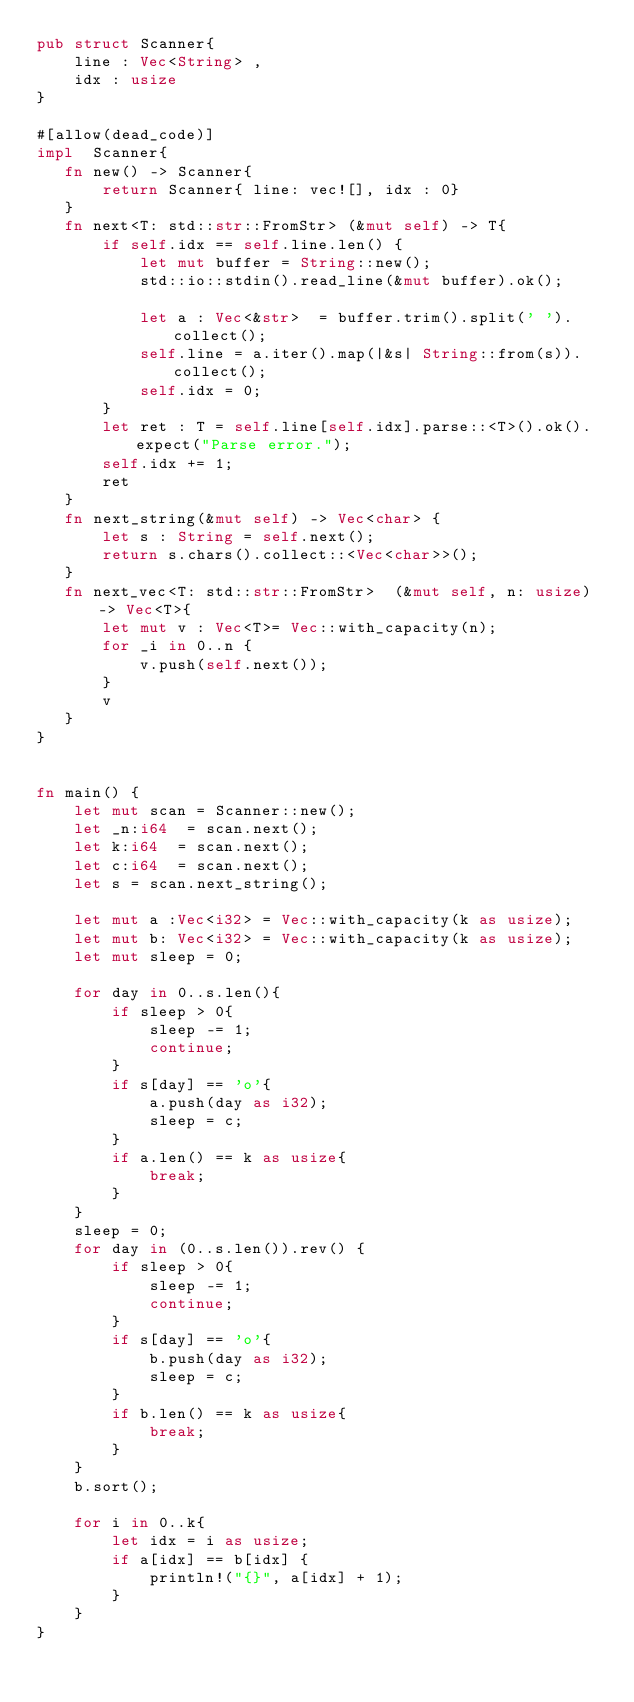Convert code to text. <code><loc_0><loc_0><loc_500><loc_500><_Rust_>pub struct Scanner{
    line : Vec<String> ,
    idx : usize
}

#[allow(dead_code)]
impl  Scanner{
   fn new() -> Scanner{
       return Scanner{ line: vec![], idx : 0}
   }
   fn next<T: std::str::FromStr> (&mut self) -> T{
       if self.idx == self.line.len() {
           let mut buffer = String::new();
           std::io::stdin().read_line(&mut buffer).ok();

           let a : Vec<&str>  = buffer.trim().split(' ').collect();
           self.line = a.iter().map(|&s| String::from(s)).collect();
           self.idx = 0;
       }
       let ret : T = self.line[self.idx].parse::<T>().ok().expect("Parse error.");
       self.idx += 1;
       ret
   }
   fn next_string(&mut self) -> Vec<char> {
       let s : String = self.next();
       return s.chars().collect::<Vec<char>>();
   }
   fn next_vec<T: std::str::FromStr>  (&mut self, n: usize) -> Vec<T>{
       let mut v : Vec<T>= Vec::with_capacity(n);
       for _i in 0..n {
           v.push(self.next());
       }
       v
   }
}


fn main() {
    let mut scan = Scanner::new();
    let _n:i64  = scan.next();
    let k:i64  = scan.next();
    let c:i64  = scan.next();
    let s = scan.next_string();

    let mut a :Vec<i32> = Vec::with_capacity(k as usize);
    let mut b: Vec<i32> = Vec::with_capacity(k as usize);
    let mut sleep = 0;

    for day in 0..s.len(){
        if sleep > 0{
            sleep -= 1;
            continue;
        }
        if s[day] == 'o'{
            a.push(day as i32);
            sleep = c;
        }
        if a.len() == k as usize{
            break;
        }
    }
    sleep = 0;
    for day in (0..s.len()).rev() {
        if sleep > 0{
            sleep -= 1;
            continue;
        }
        if s[day] == 'o'{
            b.push(day as i32);
            sleep = c;
        }
        if b.len() == k as usize{
            break;
        }
    }
    b.sort();

    for i in 0..k{
        let idx = i as usize;
        if a[idx] == b[idx] {
            println!("{}", a[idx] + 1);
        }
    }
}
</code> 